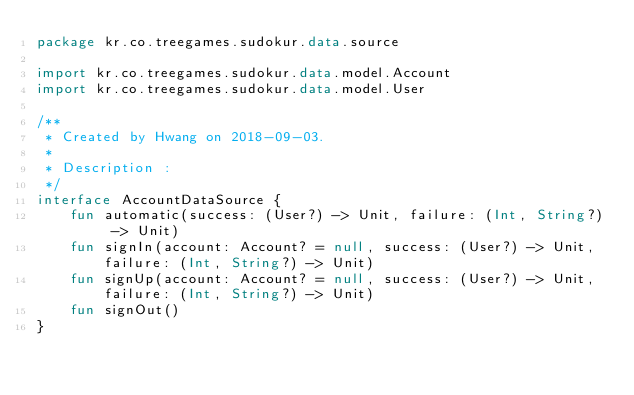Convert code to text. <code><loc_0><loc_0><loc_500><loc_500><_Kotlin_>package kr.co.treegames.sudokur.data.source

import kr.co.treegames.sudokur.data.model.Account
import kr.co.treegames.sudokur.data.model.User

/**
 * Created by Hwang on 2018-09-03.
 *
 * Description :
 */
interface AccountDataSource {
    fun automatic(success: (User?) -> Unit, failure: (Int, String?) -> Unit)
    fun signIn(account: Account? = null, success: (User?) -> Unit, failure: (Int, String?) -> Unit)
    fun signUp(account: Account? = null, success: (User?) -> Unit, failure: (Int, String?) -> Unit)
    fun signOut()
}</code> 